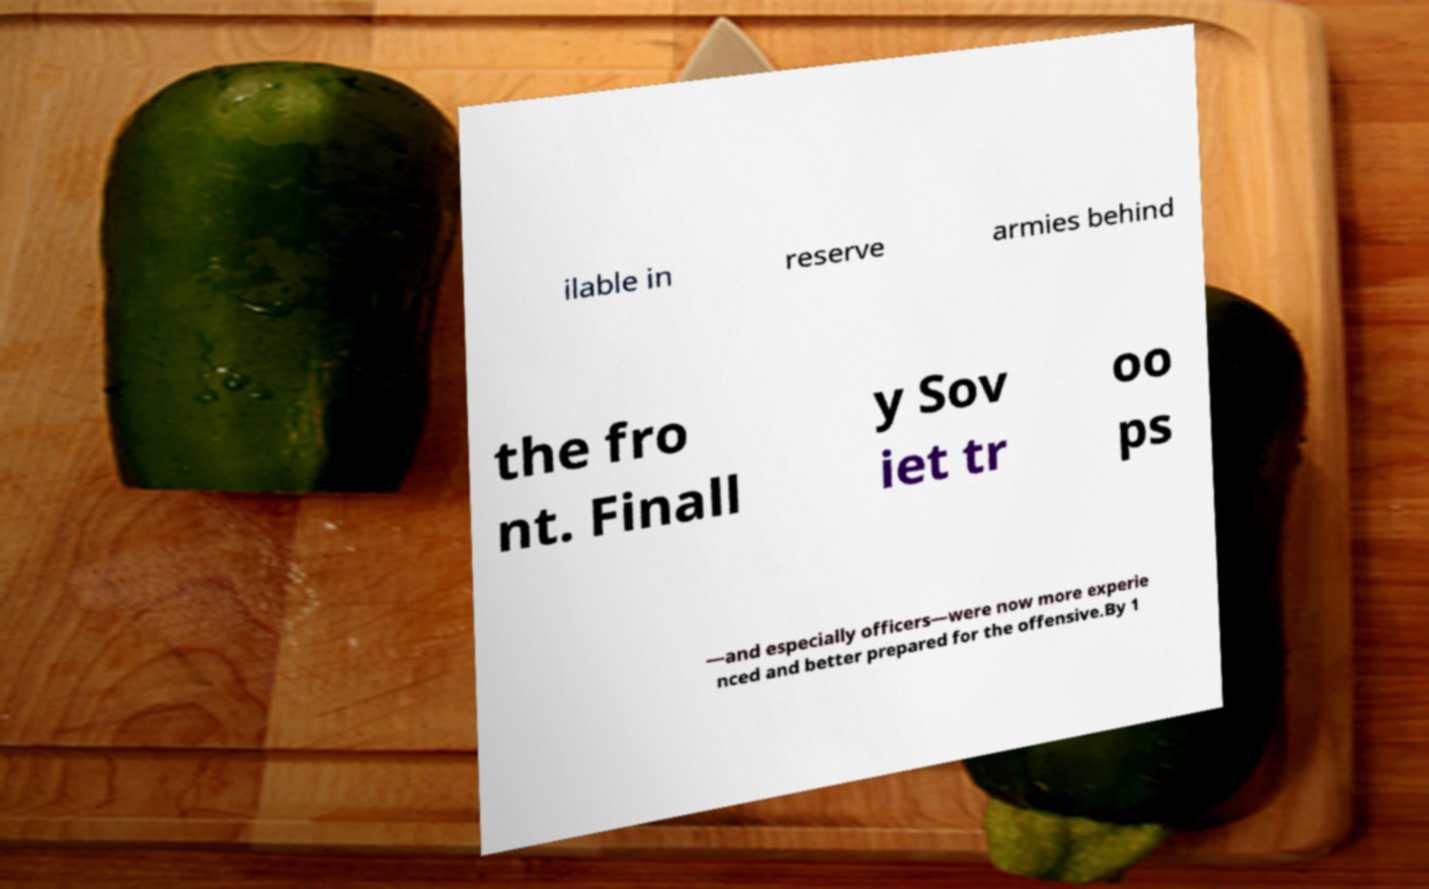Please identify and transcribe the text found in this image. ilable in reserve armies behind the fro nt. Finall y Sov iet tr oo ps —and especially officers—were now more experie nced and better prepared for the offensive.By 1 